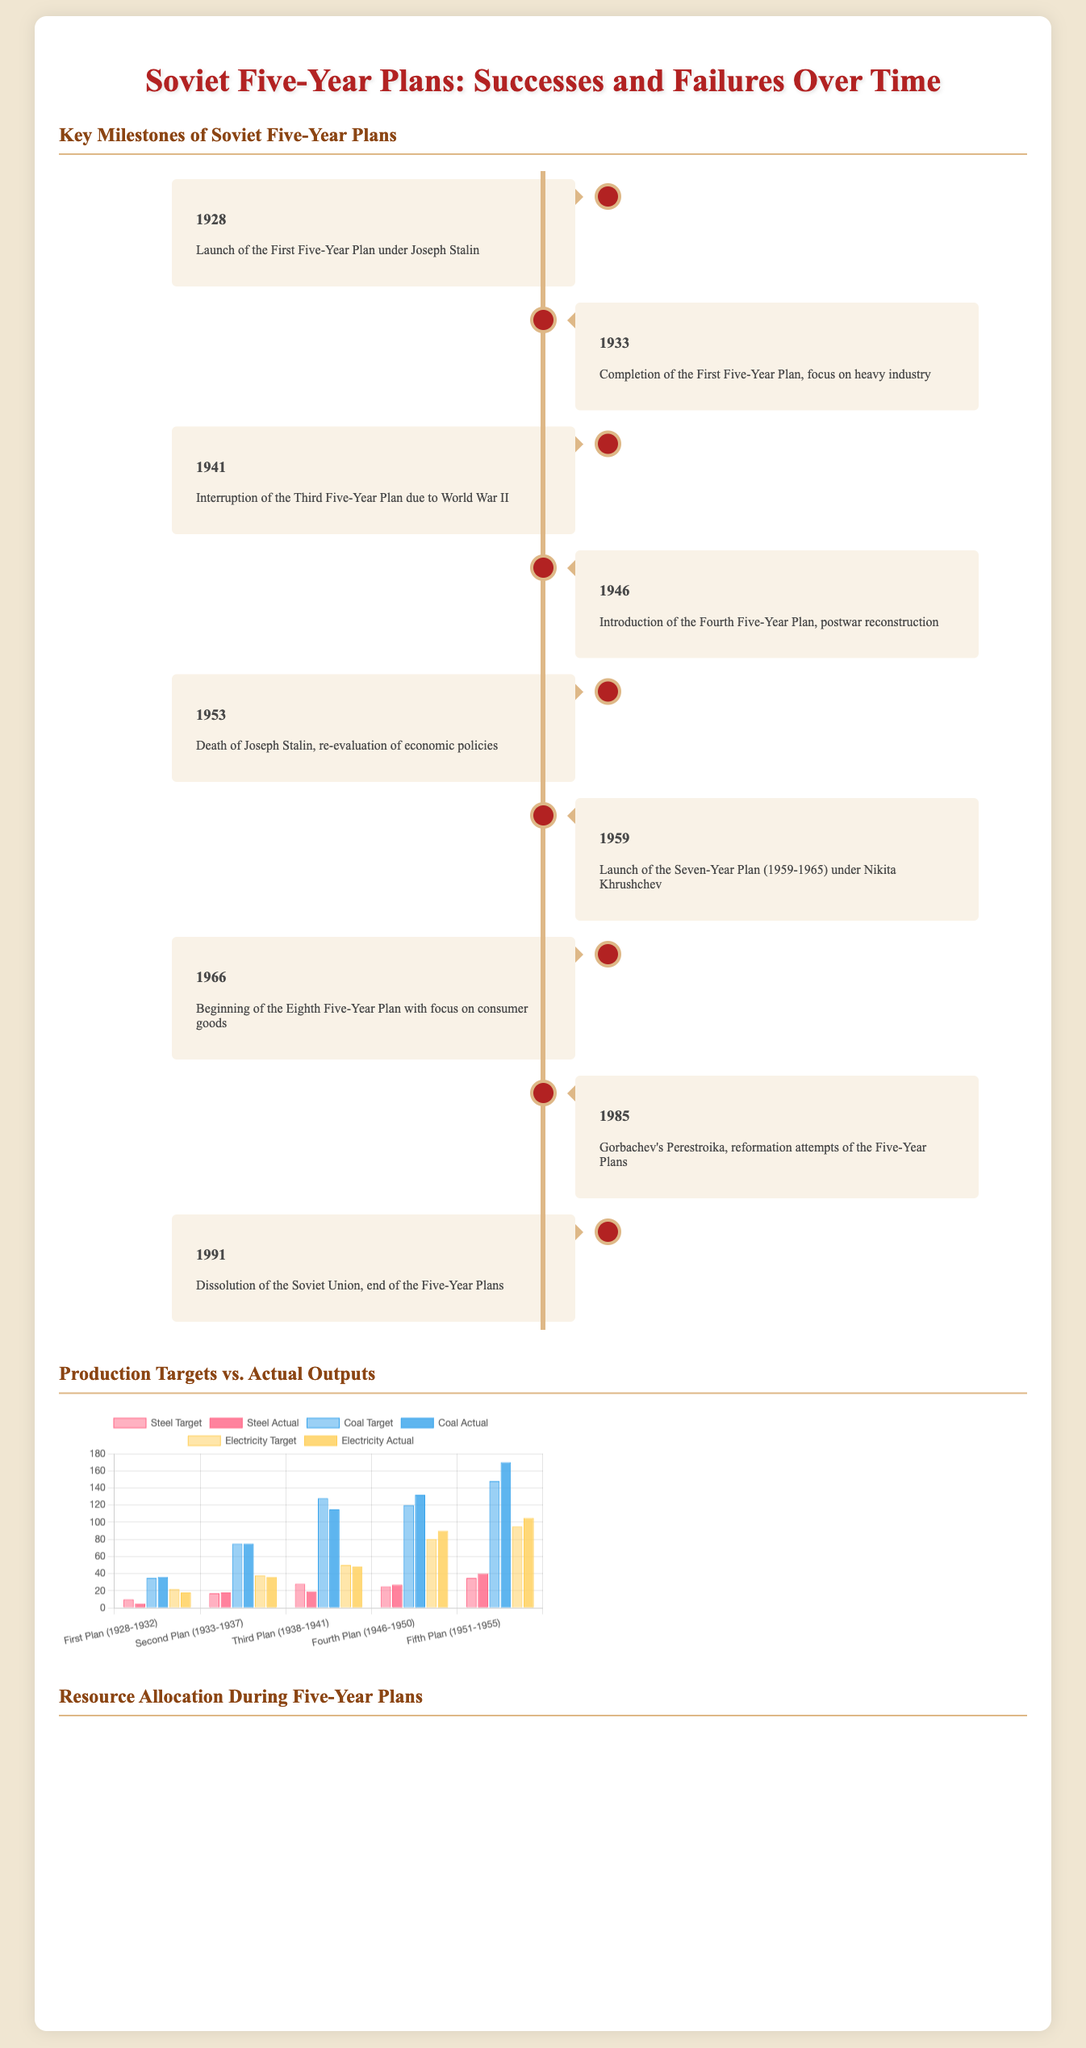What year was the First Five-Year Plan launched? The document states that the First Five-Year Plan was launched in 1928.
Answer: 1928 What is the focus of the Fourth Five-Year Plan? The document mentions that the Fourth Five-Year Plan was focused on postwar reconstruction in 1946.
Answer: Postwar reconstruction What were the actual outputs of steel in the Second Plan (1933-1937)? The chart shows that the actual output of steel during the Second Plan was 18.
Answer: 18 Which year marks the launch of the Seven-Year Plan? The document indicates that the Seven-Year Plan was launched in 1959.
Answer: 1959 What percentage of resource allocation was assigned to European Russia during the Fourth Plan? According to the heatmap, 90% of resource allocation was assigned to European Russia during the Fourth Plan.
Answer: 90% How many Five-Year Plans were launched before the death of Joseph Stalin? The timeline reveals that four Five-Year Plans were launched before Stalin's death in 1953.
Answer: Four What production target was set for electricity in the Fifth Plan (1951-1955)? The document states that the production target for electricity during the Fifth Plan was 95.
Answer: 95 Which area had the lowest resource allocation during the Second Plan? As per the heatmap, Central Asia had the lowest resource allocation (50%) during the Second Plan.
Answer: Central Asia How many key milestones are listed in the document? The timeline section contains a total of nine key milestones related to the Soviet Five-Year Plans.
Answer: Nine 